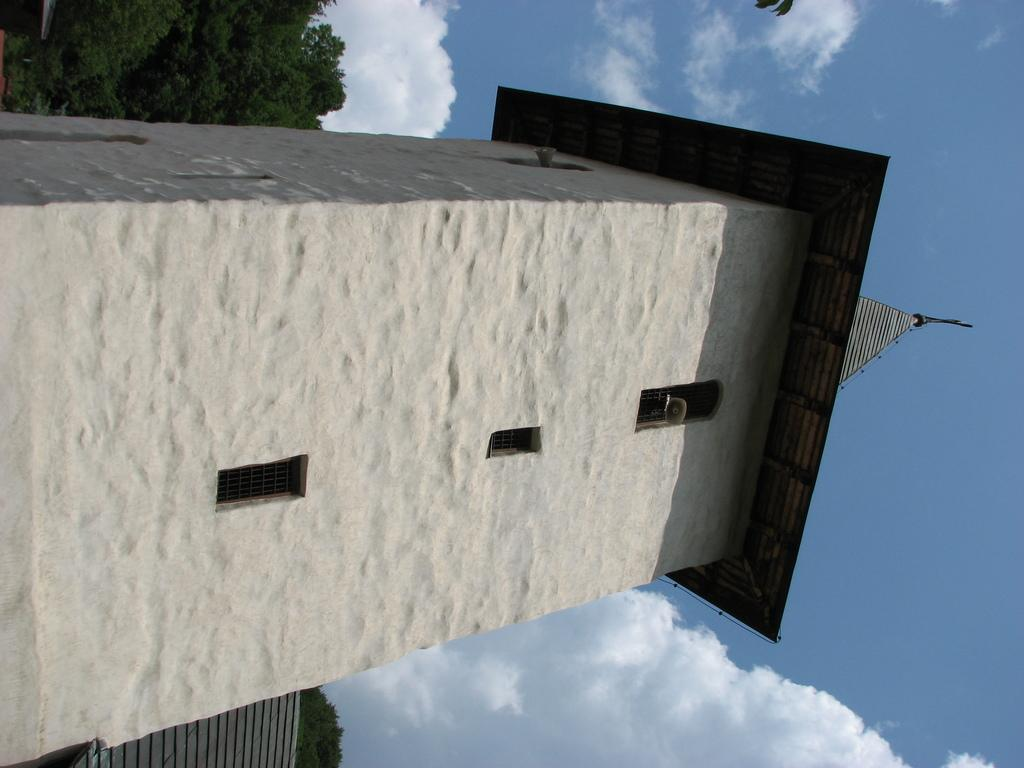What is the main subject of the image? The main subject of the image is a tower building under construction. What can be seen in the background of the image? Trees and the sky are visible in the background of the image. What is the condition of the sky in the image? Clouds are present in the sky. What type of cloth is draped over the construction site in the image? There is no cloth present in the image. 